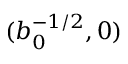<formula> <loc_0><loc_0><loc_500><loc_500>( b _ { 0 } ^ { - 1 / 2 } , 0 )</formula> 